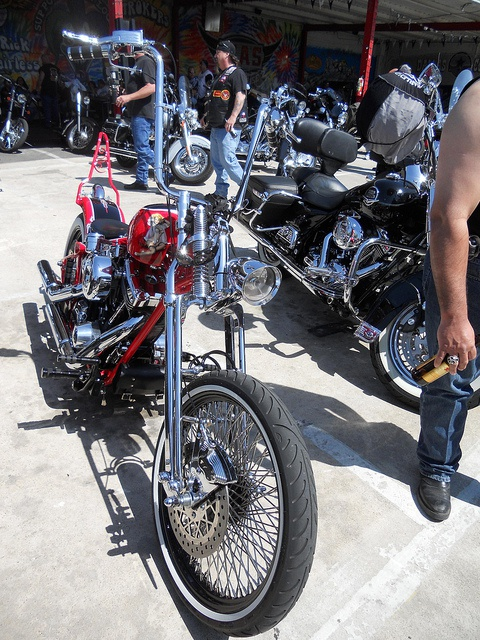Describe the objects in this image and their specific colors. I can see motorcycle in black, gray, lightgray, and darkgray tones, motorcycle in black and gray tones, people in black, gray, and tan tones, backpack in black, gray, and darkgray tones, and people in black, gray, and lightgray tones in this image. 